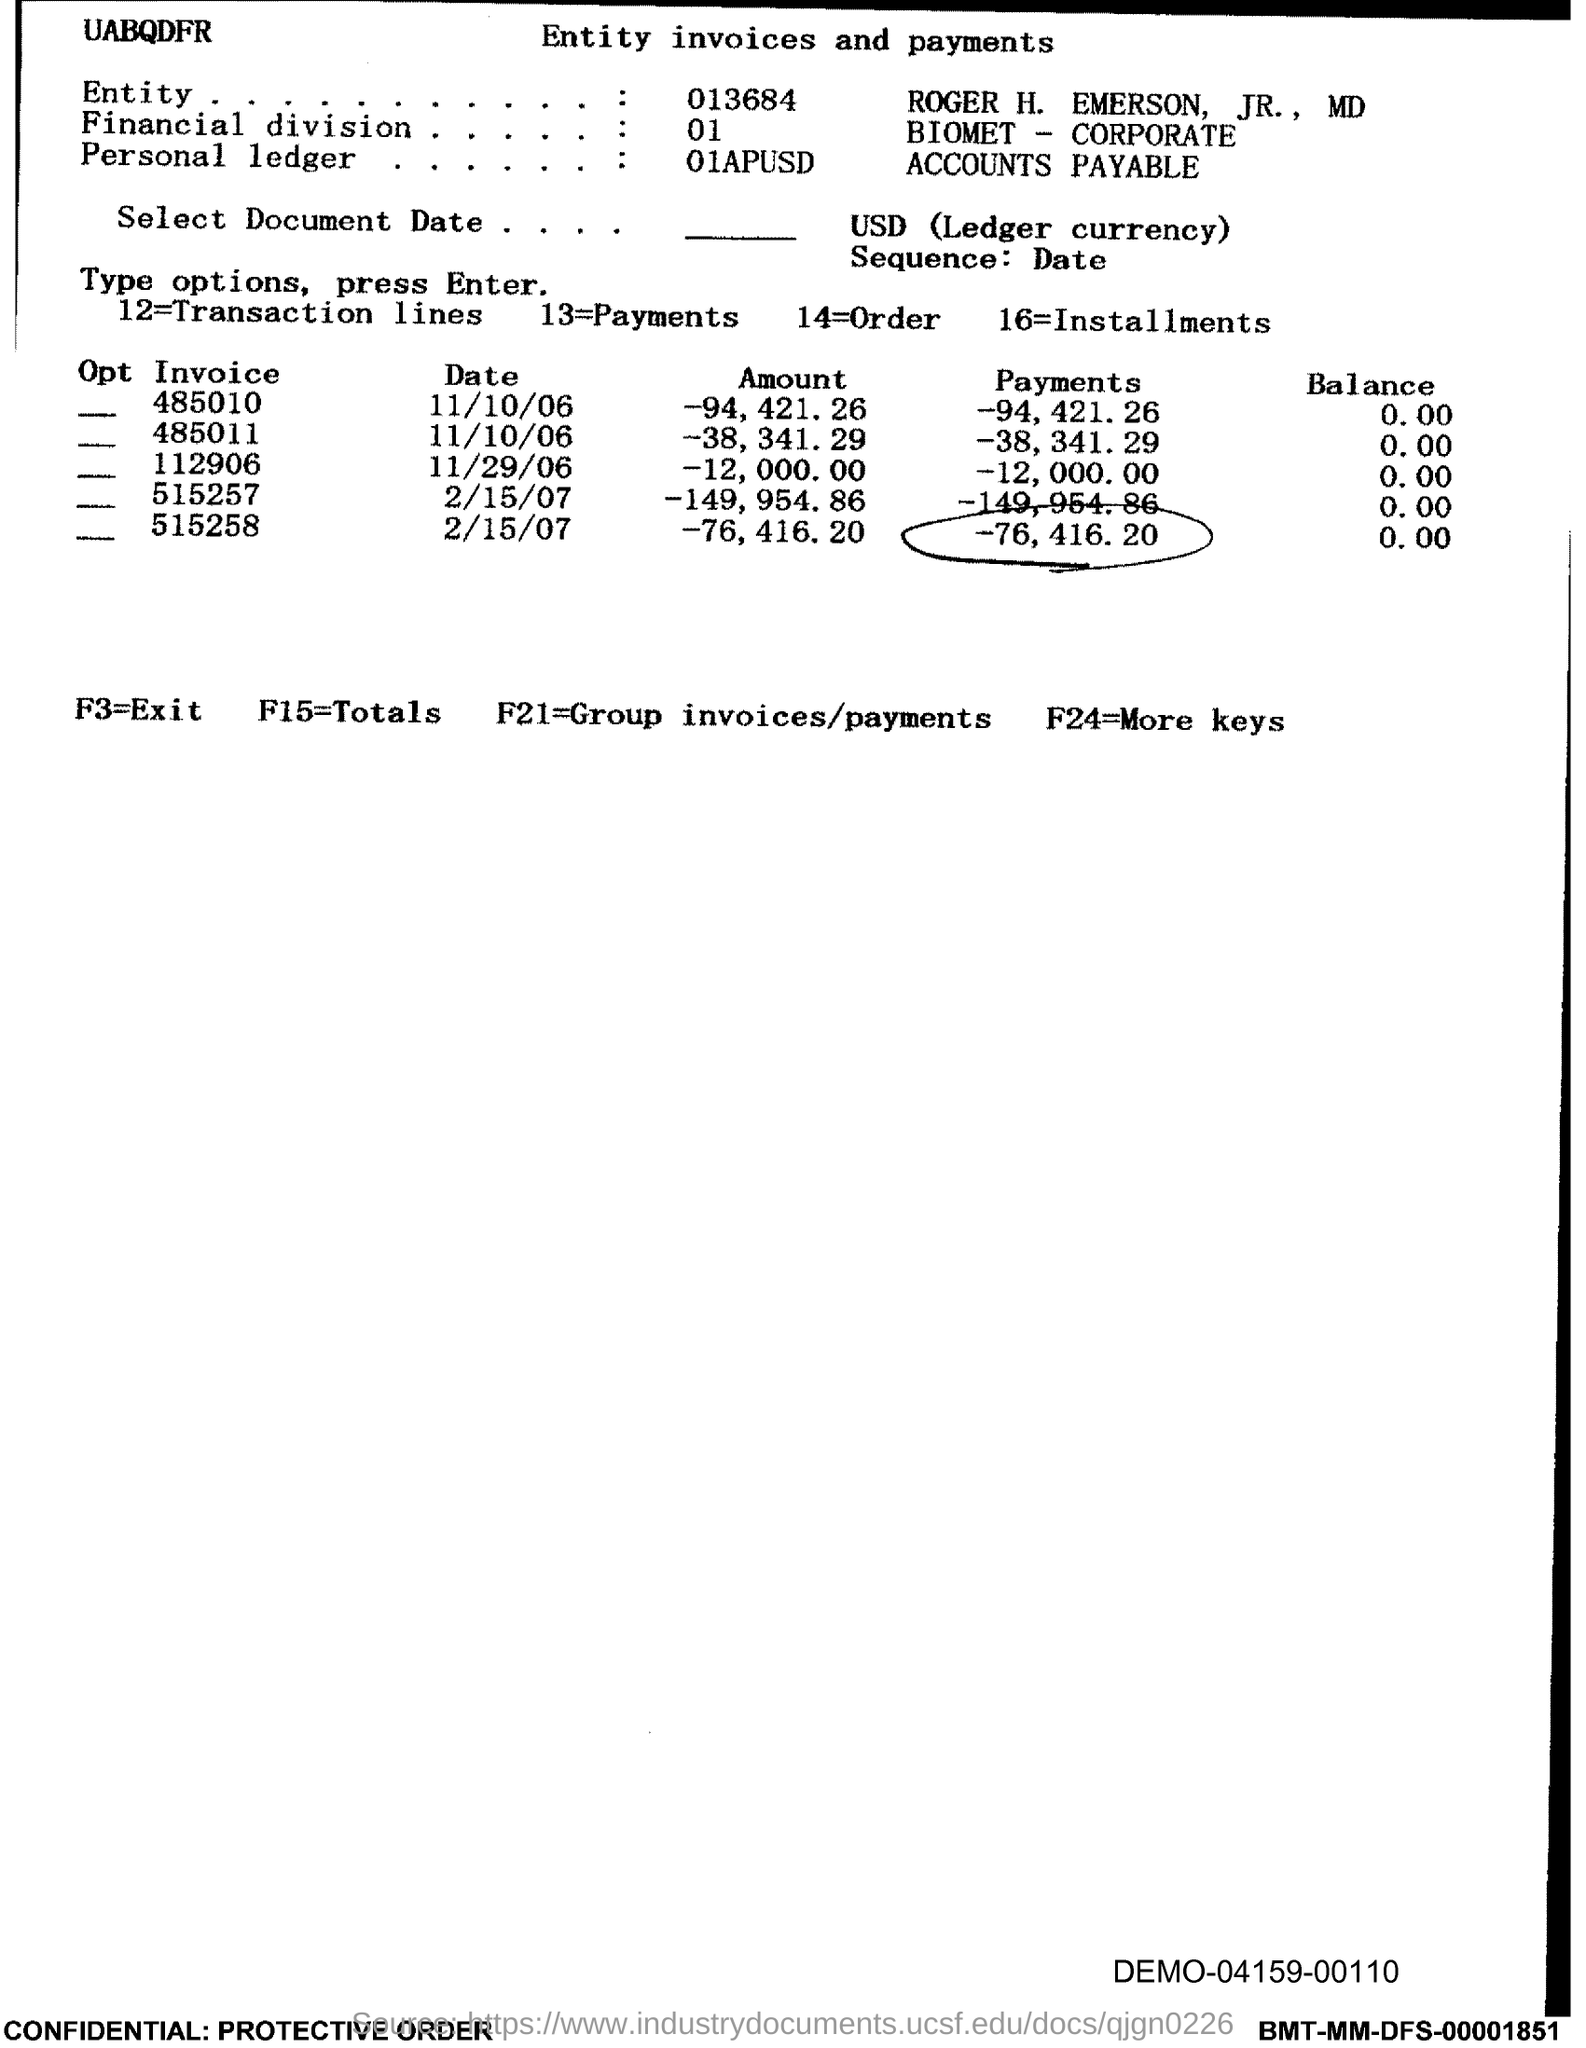Specify some key components in this picture. F3 is equal to the exit. F24 is equal to a variable that requires additional keys to be defined. The value of F15 is being calculated and the total is being displayed. 